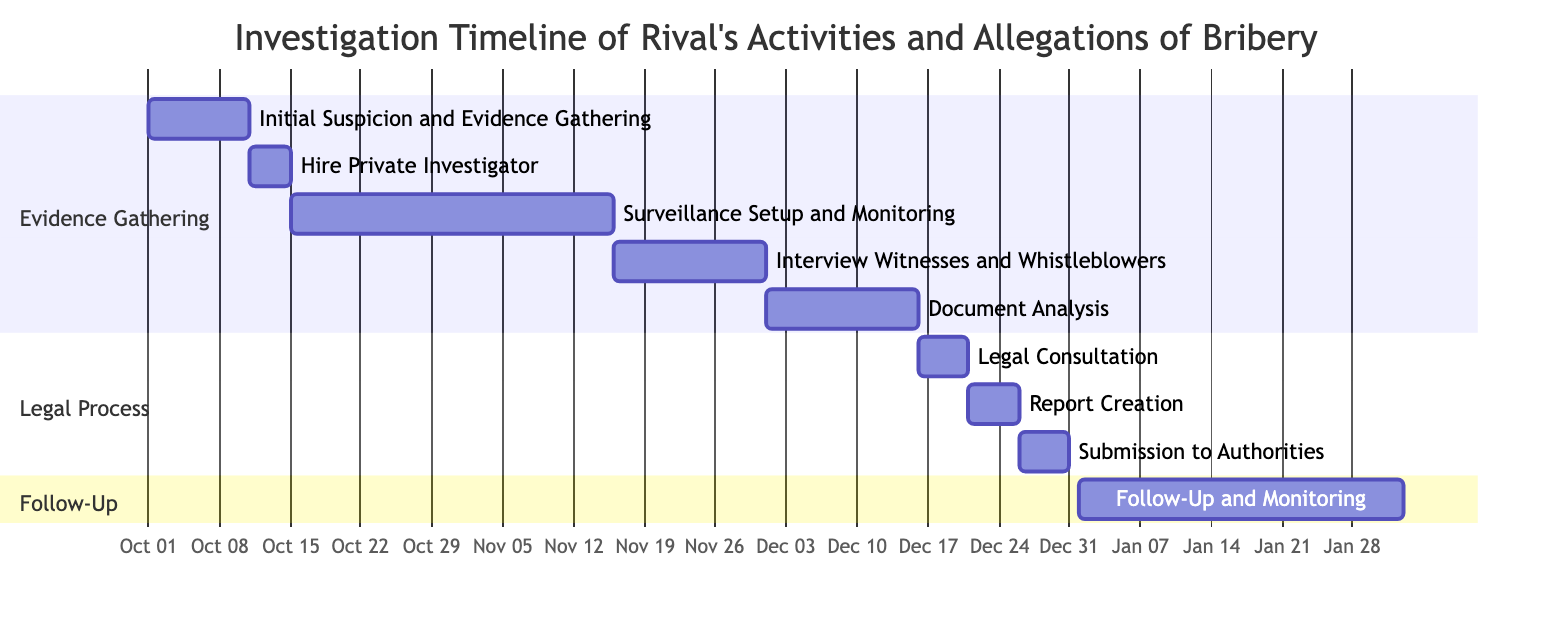What is the duration of "Surveillance Setup and Monitoring"? The task "Surveillance Setup and Monitoring" starts on October 15, 2023, and ends on November 15, 2023. Counting the days from start to end gives us 32 days.
Answer: 32 days How many tasks are in the "Legal Process" section? The "Legal Process" section includes three tasks: "Legal Consultation", "Report Creation", and "Submission to Authorities". Therefore, the total number of tasks is three.
Answer: 3 What task follows "Document Analysis"? After "Document Analysis", the next task in the timeline is "Legal Consultation”, which starts on December 16, 2023.
Answer: Legal Consultation What is the end date of the "Follow-Up and Monitoring" task? The "Follow-Up and Monitoring" task starts on January 1, 2024, and lasts for 32 days, leading to its end date being February 1, 2024.
Answer: February 1, 2024 Which task has the earliest start date? The task "Initial Suspicion and Evidence Gathering" has the earliest start date of October 1, 2023, compared to the other tasks.
Answer: Initial Suspicion and Evidence Gathering How many days are allocated for "Interview Witnesses and Whistleblowers"? The duration of "Interview Witnesses and Whistleblowers" is a span of 15 days, starting on November 16, 2023, and ending on November 30, 2023.
Answer: 15 days What are the tasks in the "Evidence Gathering" section? The "Evidence Gathering" section consists of five tasks: "Initial Suspicion and Evidence Gathering", "Hire Private Investigator", "Surveillance Setup and Monitoring", "Interview Witnesses and Whistleblowers", and "Document Analysis".
Answer: Five tasks What is the total duration of the investigation from the start of the first task to the end of the last task? The investigation begins on October 1, 2023, and ends on February 1, 2024. The total duration from the start to the end is 123 days (from October 1 to February 1 inclusive).
Answer: 123 days 